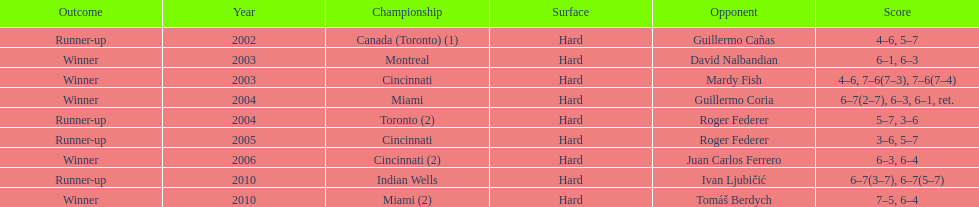In toronto or montreal, how many championship events have been held? 3. 